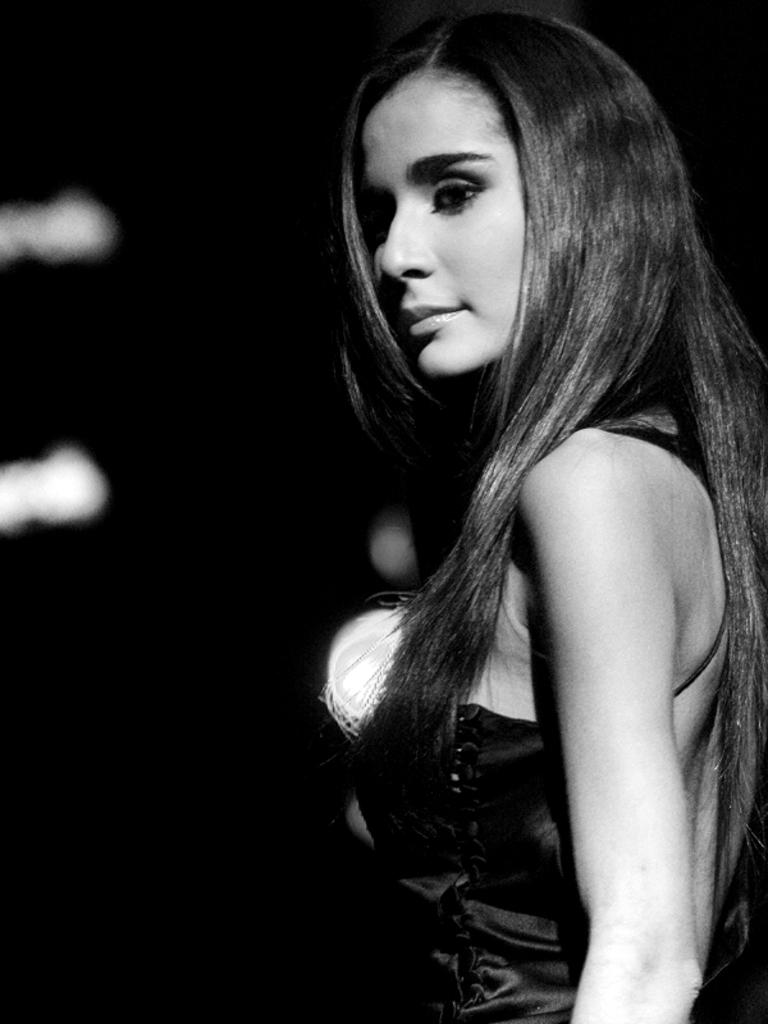What is the main subject of the image? There is a woman standing in the image. What can be seen in addition to the woman? There are lights in the image. How would you describe the overall appearance of the image? The background of the image is dark. What type of mint is being crushed under the woman's foot in the image? There is no mint or any indication of crushing in the image. 